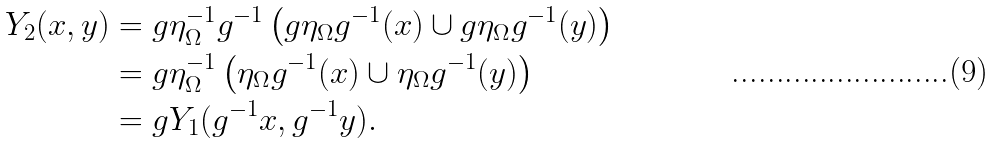<formula> <loc_0><loc_0><loc_500><loc_500>Y _ { 2 } ( x , y ) & = g \eta _ { \Omega } ^ { - 1 } g ^ { - 1 } \left ( g \eta _ { \Omega } g ^ { - 1 } ( x ) \cup g \eta _ { \Omega } g ^ { - 1 } ( y ) \right ) \\ & = g \eta _ { \Omega } ^ { - 1 } \left ( \eta _ { \Omega } g ^ { - 1 } ( x ) \cup \eta _ { \Omega } g ^ { - 1 } ( y ) \right ) \\ & = g Y _ { 1 } ( g ^ { - 1 } x , g ^ { - 1 } y ) .</formula> 